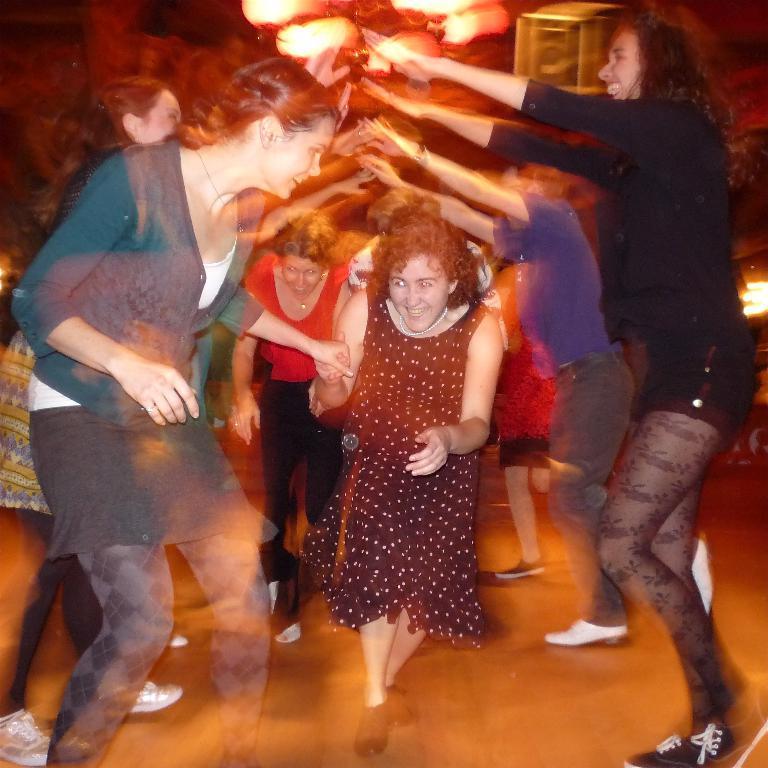Describe this image in one or two sentences. In this picture I can see a group of people are standing and smiling. In the background I can see lights. 